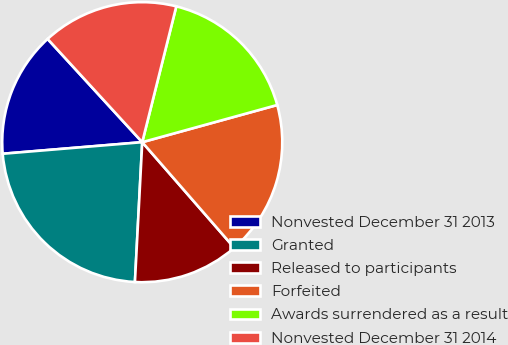Convert chart. <chart><loc_0><loc_0><loc_500><loc_500><pie_chart><fcel>Nonvested December 31 2013<fcel>Granted<fcel>Released to participants<fcel>Forfeited<fcel>Awards surrendered as a result<fcel>Nonvested December 31 2014<nl><fcel>14.51%<fcel>22.85%<fcel>12.24%<fcel>17.87%<fcel>16.81%<fcel>15.72%<nl></chart> 